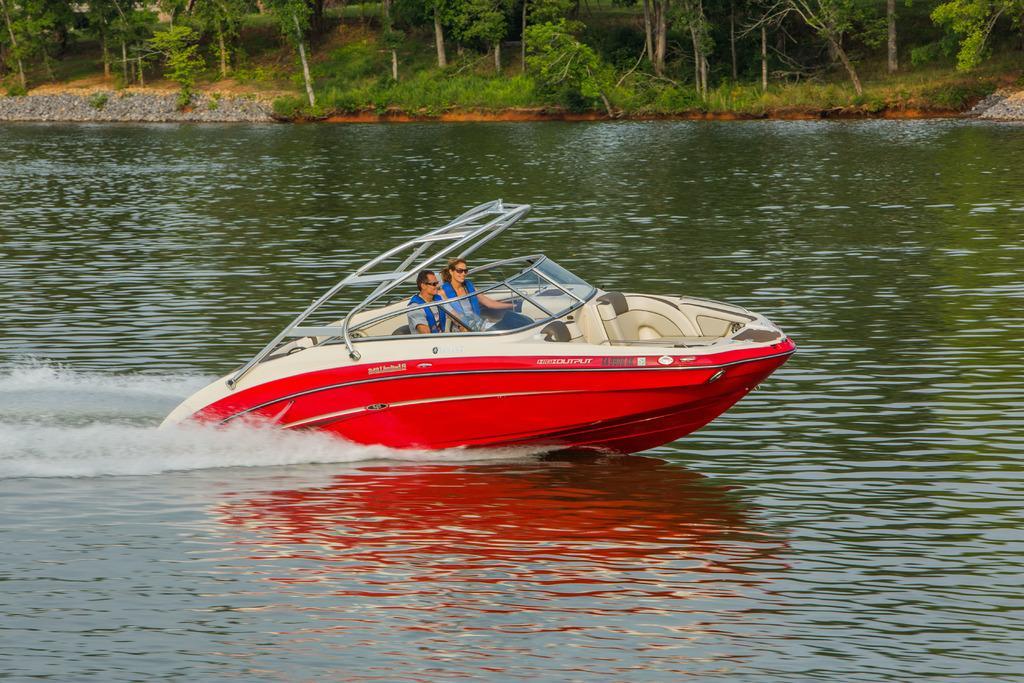Can you describe this image briefly? In this image I see a boat which is of white and red in color and I see a man and a woman on it and I see the water. In the background I see the ground on which I see grass, plants and the trees. 